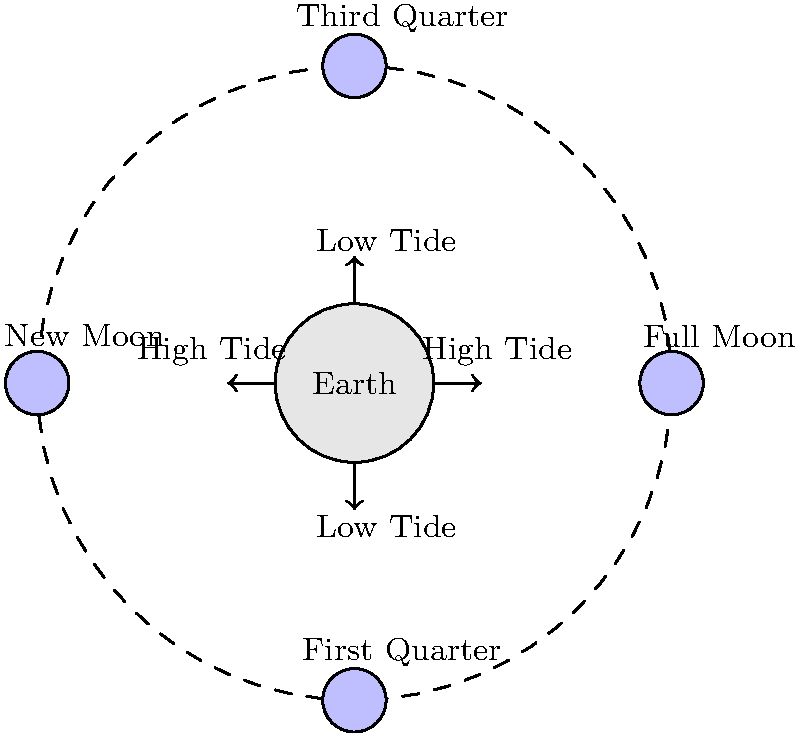As the leader of a remote community relying on external aid for health needs, understanding natural cycles is crucial. How do the moon's phases affect tidal patterns, and what phase would cause the most extreme tides, potentially impacting coastal access for aid deliveries? 1. Moon phases and tides are closely related due to gravitational forces:
   - The moon's gravity pulls on Earth's oceans, causing tides.
   - The sun also affects tides, but to a lesser extent.

2. Tidal patterns:
   - High tides occur on the side of Earth facing the moon and the opposite side.
   - Low tides occur perpendicular to the high tides.

3. Lunar phases and their impact:
   - New Moon: Moon is between Earth and Sun
   - Full Moon: Earth is between Moon and Sun
   - First Quarter and Third Quarter: Moon is at a right angle to Earth and Sun

4. Spring tides:
   - Occur during New Moon and Full Moon
   - Sun, Earth, and Moon are aligned
   - Gravitational forces of Sun and Moon combine
   - Result in higher high tides and lower low tides

5. Neap tides:
   - Occur during First Quarter and Third Quarter
   - Sun and Moon are at right angles to Earth
   - Gravitational forces partially cancel out
   - Result in lower high tides and higher low tides

6. Most extreme tides:
   - Happen during Spring tides (New Moon or Full Moon)
   - Particularly extreme when the Moon is at its closest point to Earth (perigee)
   - This combination is sometimes called a "Supermoon" or "King Tide"

7. Impact on coastal access:
   - Extreme high tides could flood coastal areas, potentially blocking access
   - Extreme low tides could expose hazards or make some ports inaccessible
   - Planning aid deliveries around these tidal extremes is crucial for safety and efficiency
Answer: Full Moon or New Moon (Spring tides), especially during a Supermoon 